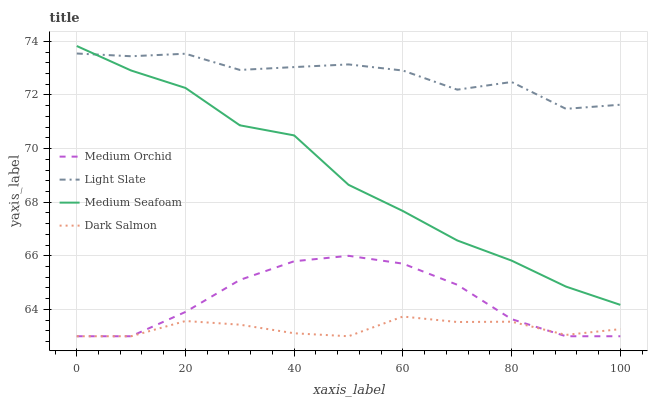Does Dark Salmon have the minimum area under the curve?
Answer yes or no. Yes. Does Light Slate have the maximum area under the curve?
Answer yes or no. Yes. Does Medium Orchid have the minimum area under the curve?
Answer yes or no. No. Does Medium Orchid have the maximum area under the curve?
Answer yes or no. No. Is Dark Salmon the smoothest?
Answer yes or no. Yes. Is Light Slate the roughest?
Answer yes or no. Yes. Is Medium Orchid the smoothest?
Answer yes or no. No. Is Medium Orchid the roughest?
Answer yes or no. No. Does Medium Orchid have the lowest value?
Answer yes or no. Yes. Does Medium Seafoam have the lowest value?
Answer yes or no. No. Does Medium Seafoam have the highest value?
Answer yes or no. Yes. Does Medium Orchid have the highest value?
Answer yes or no. No. Is Medium Orchid less than Medium Seafoam?
Answer yes or no. Yes. Is Light Slate greater than Dark Salmon?
Answer yes or no. Yes. Does Medium Orchid intersect Dark Salmon?
Answer yes or no. Yes. Is Medium Orchid less than Dark Salmon?
Answer yes or no. No. Is Medium Orchid greater than Dark Salmon?
Answer yes or no. No. Does Medium Orchid intersect Medium Seafoam?
Answer yes or no. No. 